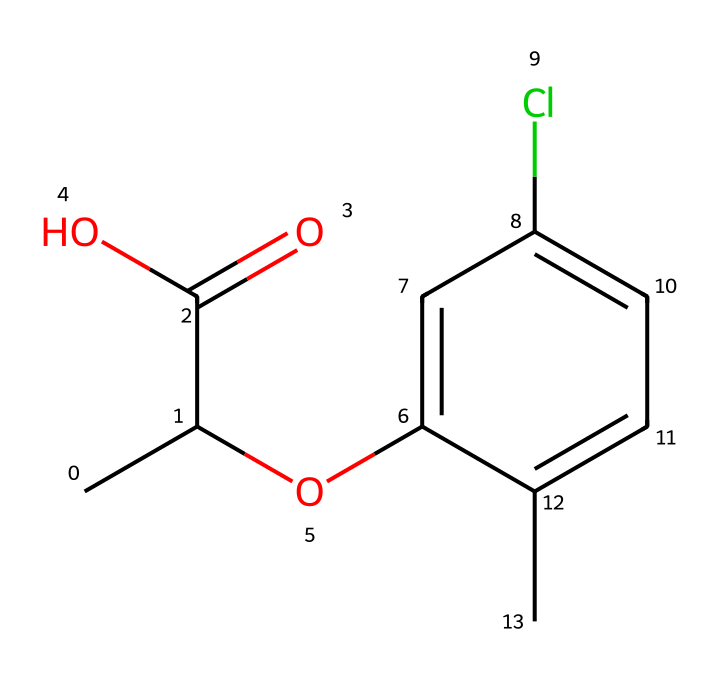What is the molecular formula of mecoprop? To determine the molecular formula, we can count all the atoms present in the SMILES representation. The structure contains 11 carbon (C) atoms, 13 hydrogen (H) atoms, 2 oxygen (O) atoms, and 1 chlorine (Cl) atom. Combining these gives us the molecular formula C11H13ClO2.
Answer: C11H13ClO2 How many rings are present in the structure of mecoprop? By analyzing the SMILES representation, we can search for any cyclical formations. The letter "c" indicates aromatic carbon atoms, and "c1" starts a ring structure. The structure has one ring present.
Answer: 1 Which functional group is represented by “C(=O)O” in mecoprop? The "C(=O)O" part of the SMILES shows a carbon atom double bonded to an oxygen (O) atom and single bonded to another oxygen (O) atom, indicating a carboxylic acid functional group.
Answer: carboxylic acid What is the role of the chlorine atom in mecoprop? The chlorine atom in the structure likely contributes to the herbicidal activity of mecoprop by influencing the chemical's reactivity and stability, often enhancing its ability to affect plant growth.
Answer: herbicidal activity What type of herbicide is mecoprop classified as? Mecoprop is classified as a phenoxy herbicide, which is a group of chemicals that mimic plant hormones to disrupt growth processes in broadleaf weeds.
Answer: phenoxy herbicide How many oxygen atoms are present in the mecoprop molecule? From the molecular structure illustrated in the SMILES code, we can count two distinct oxygen atoms in total, represented by "O" in the carboxylic acid and the ether part of the structure.
Answer: 2 Which part of the mecoprop structure is responsible for its solubility in water? The hydroxyl (–OH) group present in the carboxylic acid part of mecoprop enhances its polarity, contributing to its solubility in water through hydrogen bonding.
Answer: hydroxyl group 